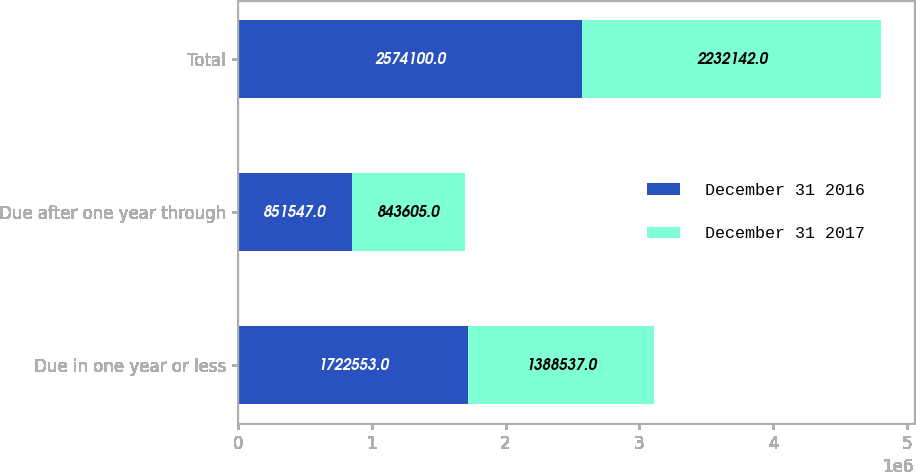Convert chart to OTSL. <chart><loc_0><loc_0><loc_500><loc_500><stacked_bar_chart><ecel><fcel>Due in one year or less<fcel>Due after one year through<fcel>Total<nl><fcel>December 31 2016<fcel>1.72255e+06<fcel>851547<fcel>2.5741e+06<nl><fcel>December 31 2017<fcel>1.38854e+06<fcel>843605<fcel>2.23214e+06<nl></chart> 